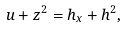Convert formula to latex. <formula><loc_0><loc_0><loc_500><loc_500>u + z ^ { 2 } = h _ { x } + h ^ { 2 } ,</formula> 